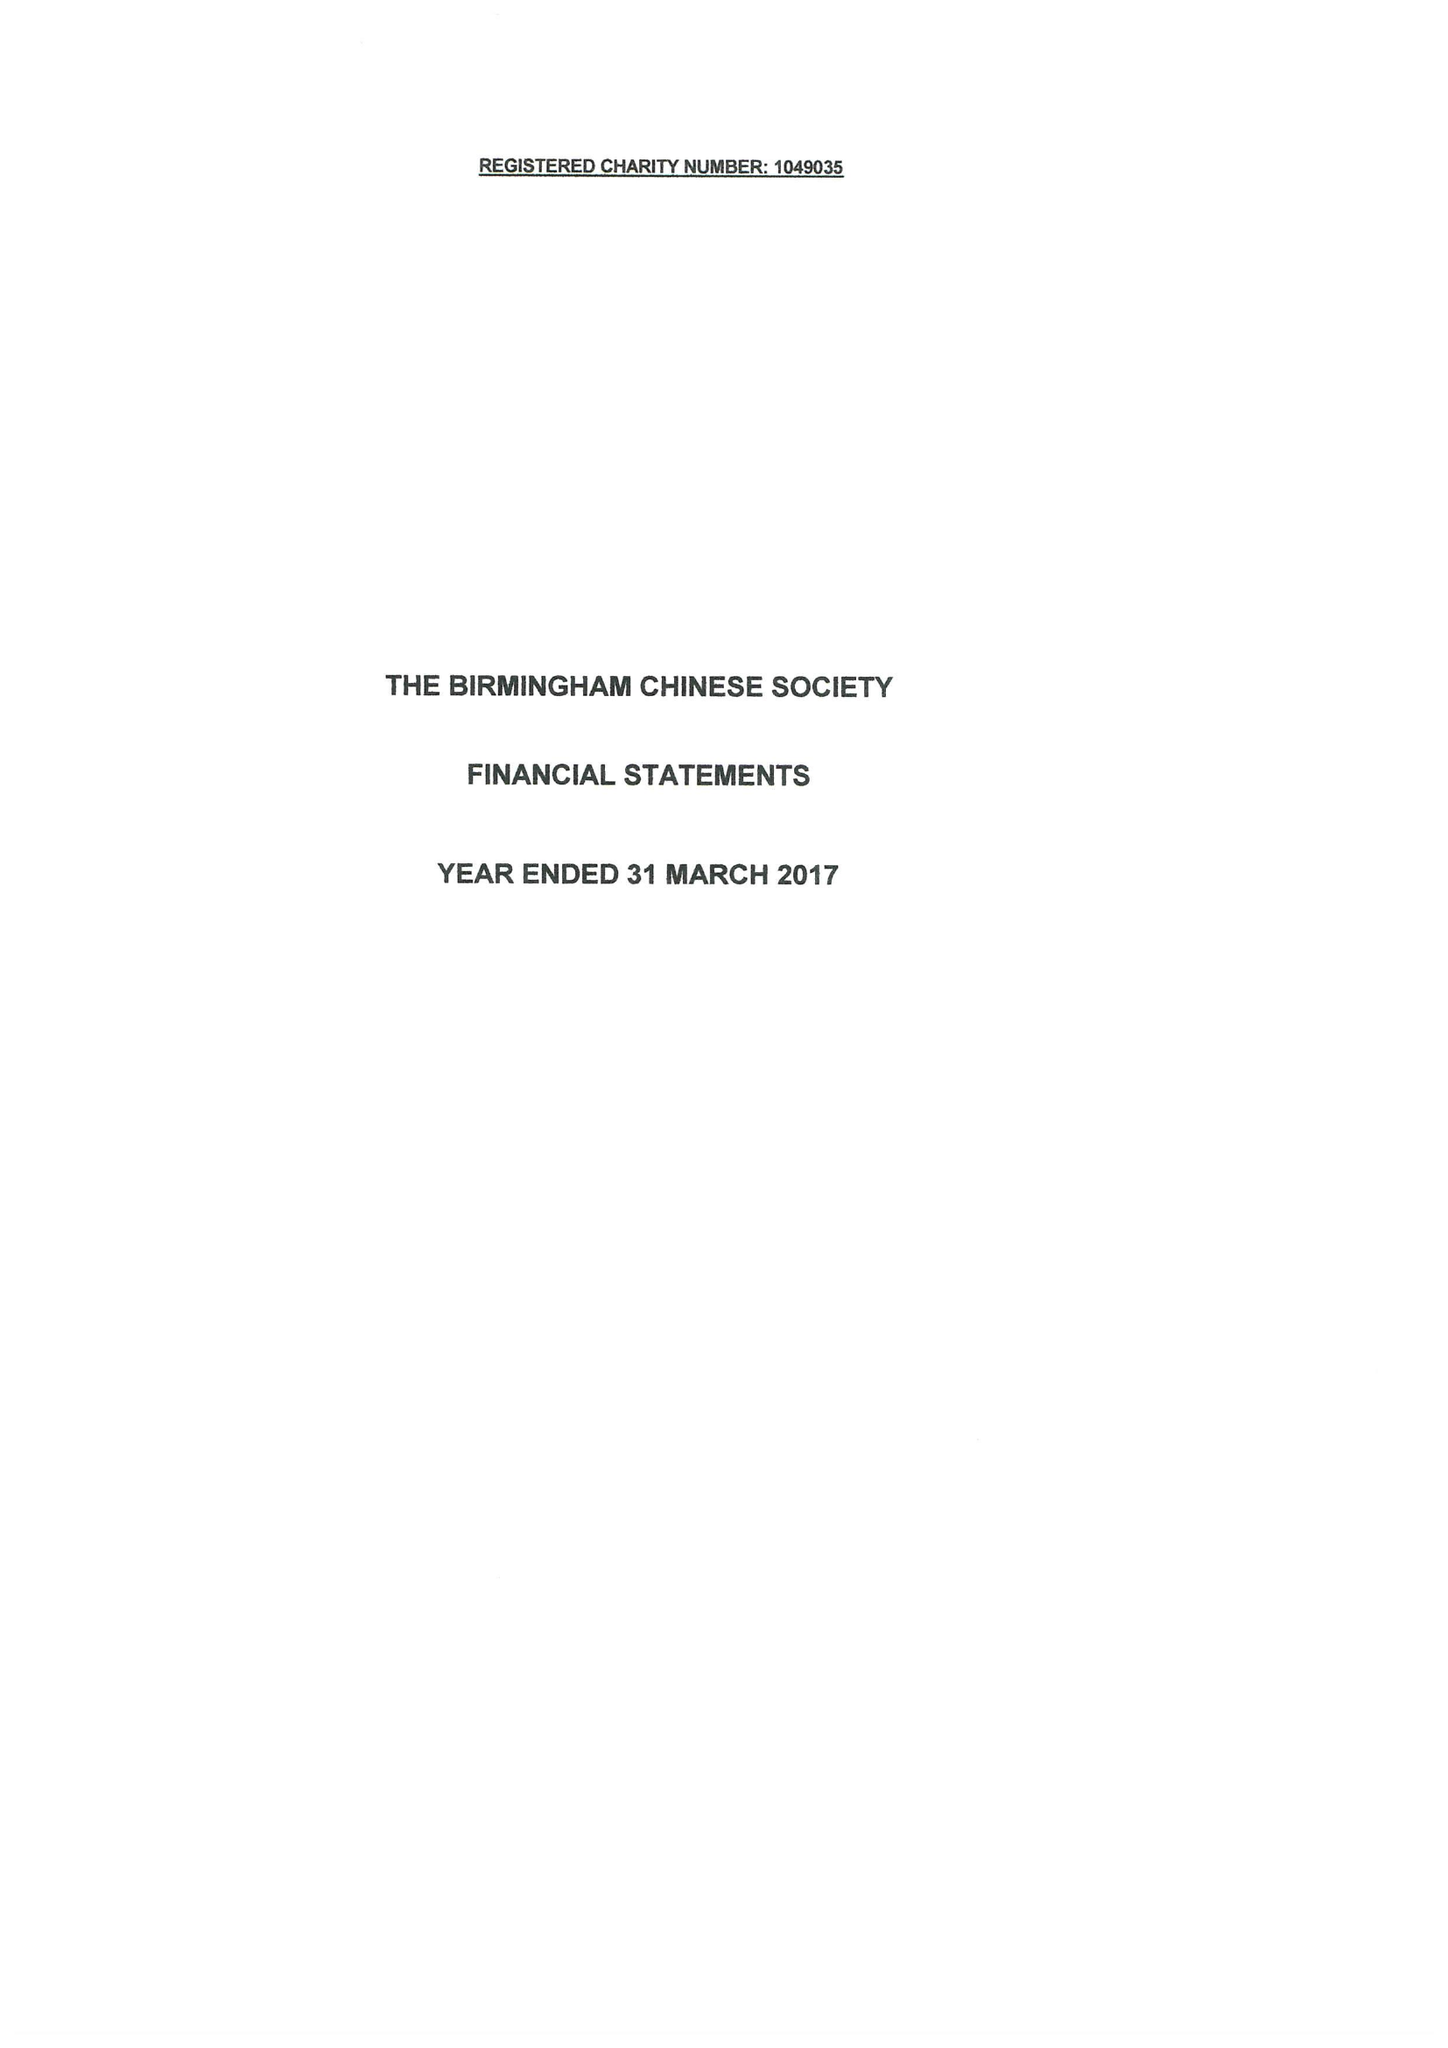What is the value for the charity_name?
Answer the question using a single word or phrase. The Birmingham Chinese Society 